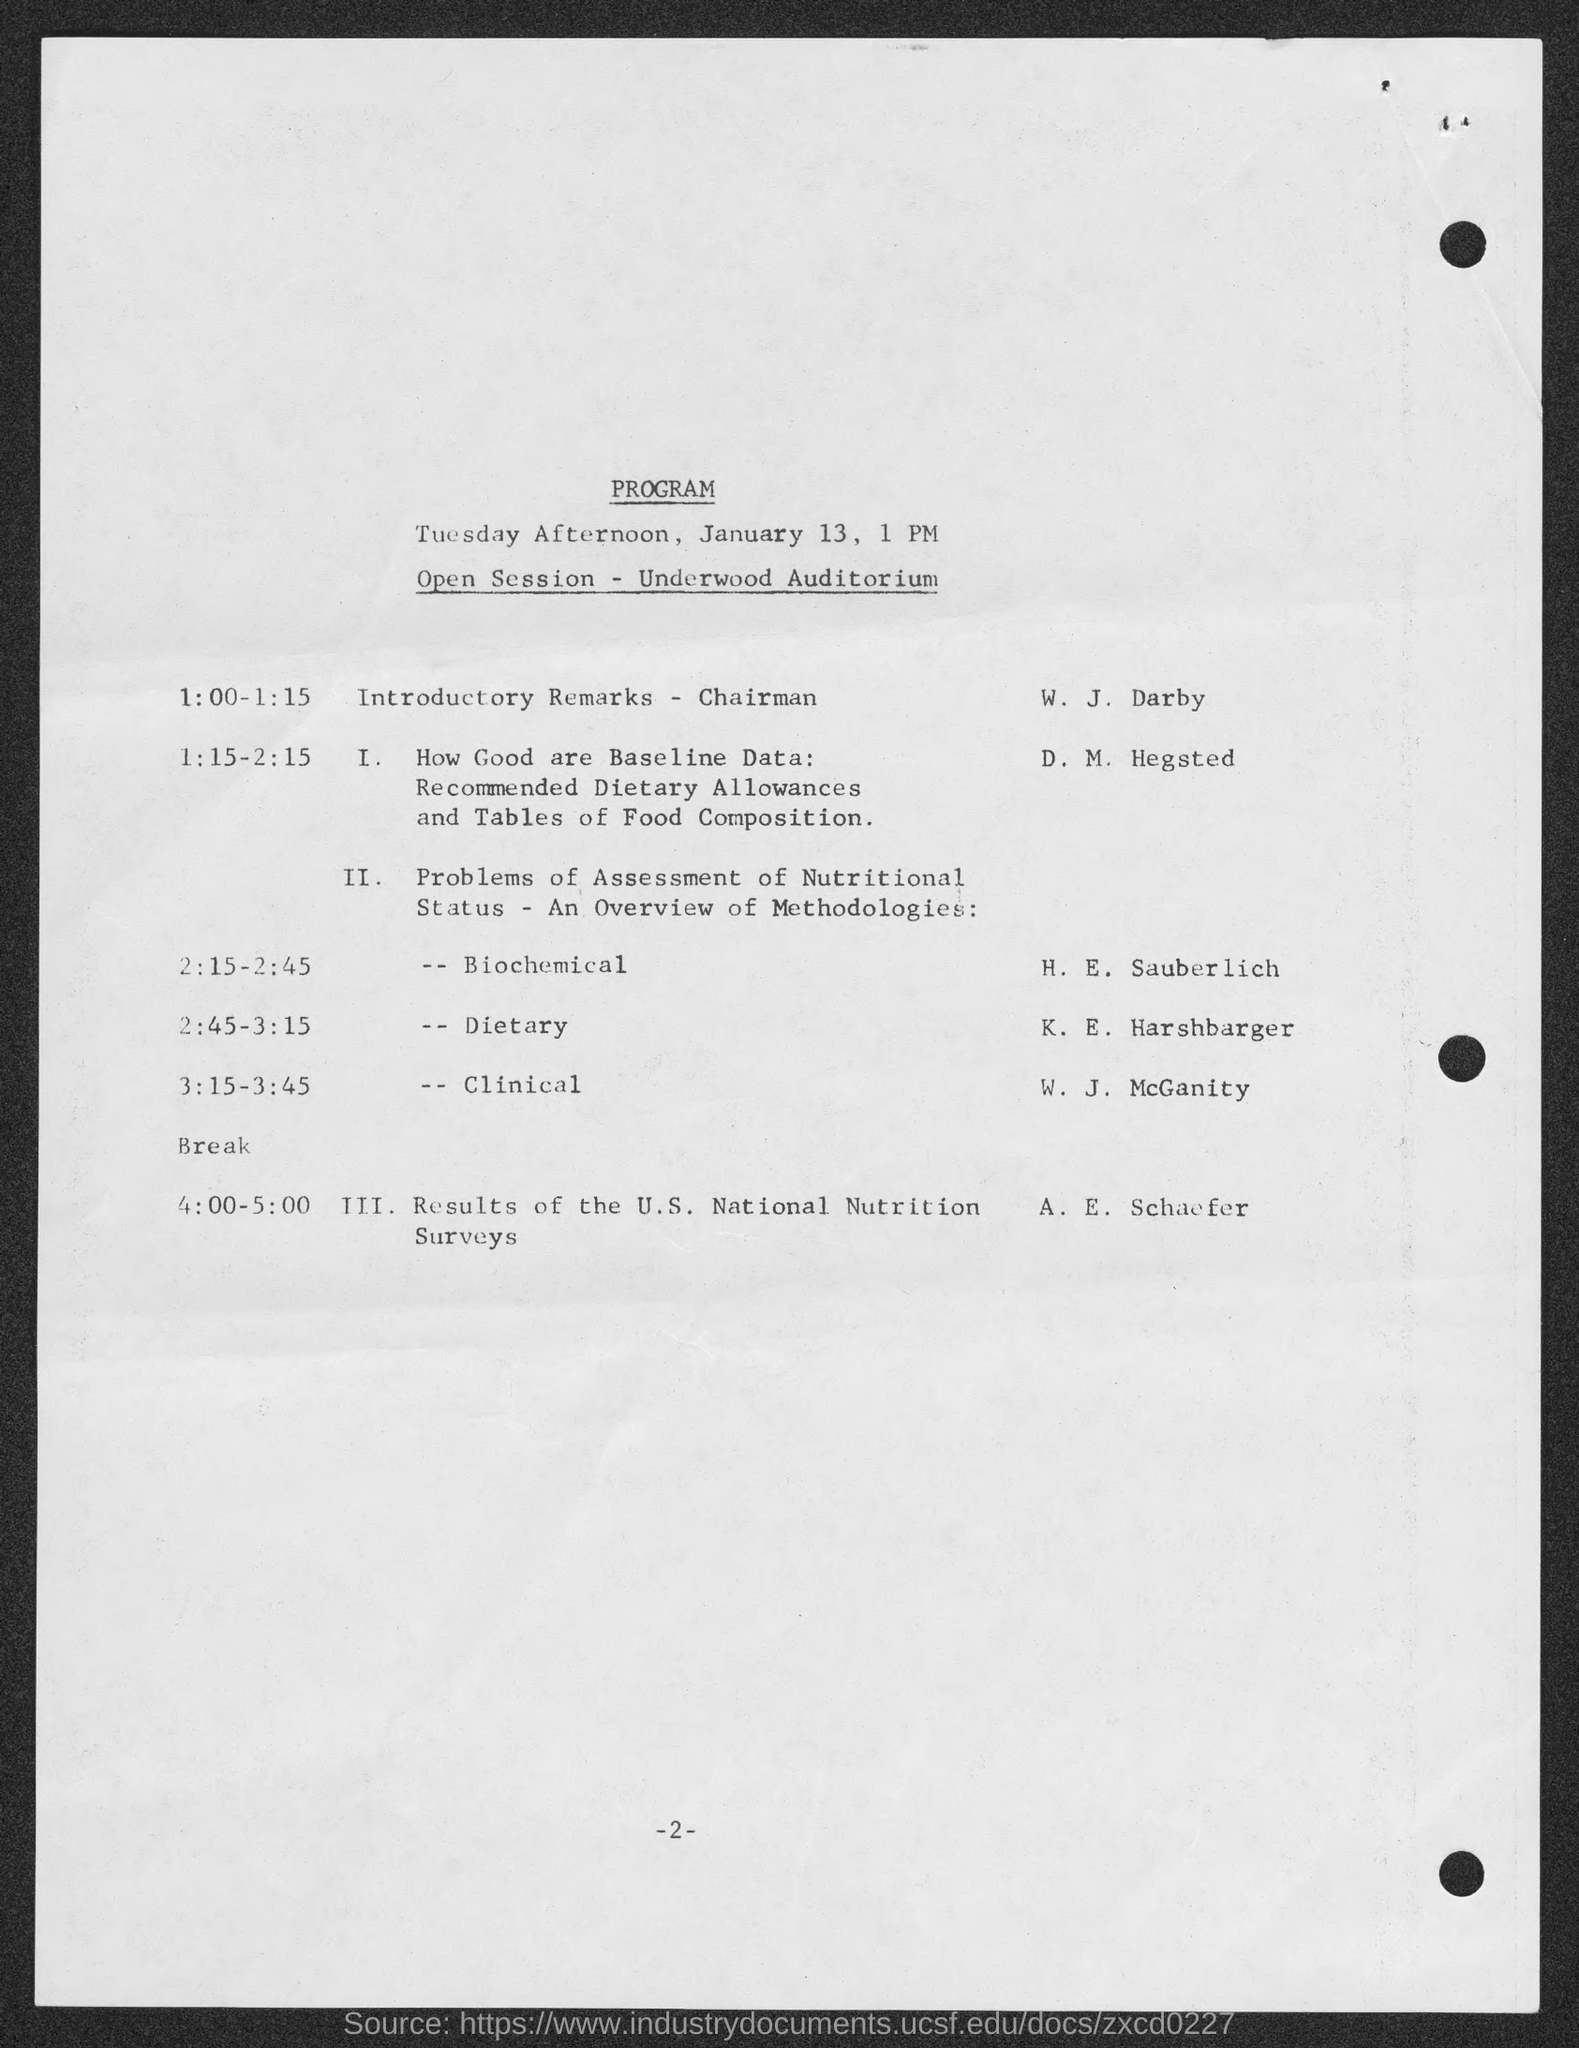Draw attention to some important aspects in this diagram. W. J. Darby is giving the introductory remarks. 